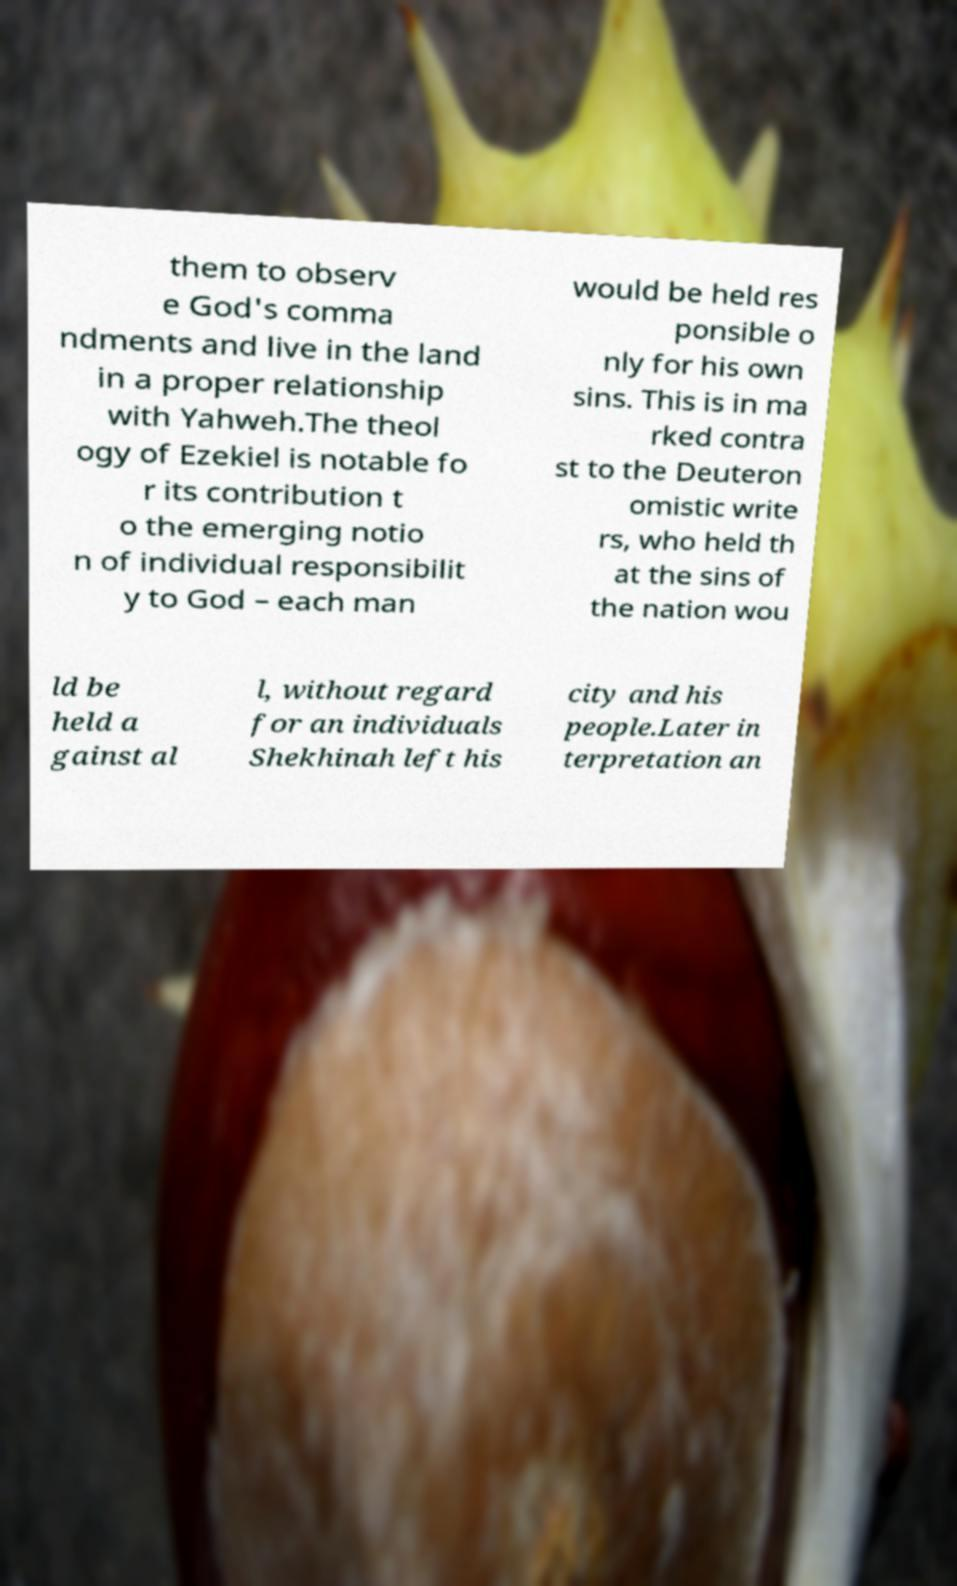Could you assist in decoding the text presented in this image and type it out clearly? them to observ e God's comma ndments and live in the land in a proper relationship with Yahweh.The theol ogy of Ezekiel is notable fo r its contribution t o the emerging notio n of individual responsibilit y to God – each man would be held res ponsible o nly for his own sins. This is in ma rked contra st to the Deuteron omistic write rs, who held th at the sins of the nation wou ld be held a gainst al l, without regard for an individuals Shekhinah left his city and his people.Later in terpretation an 